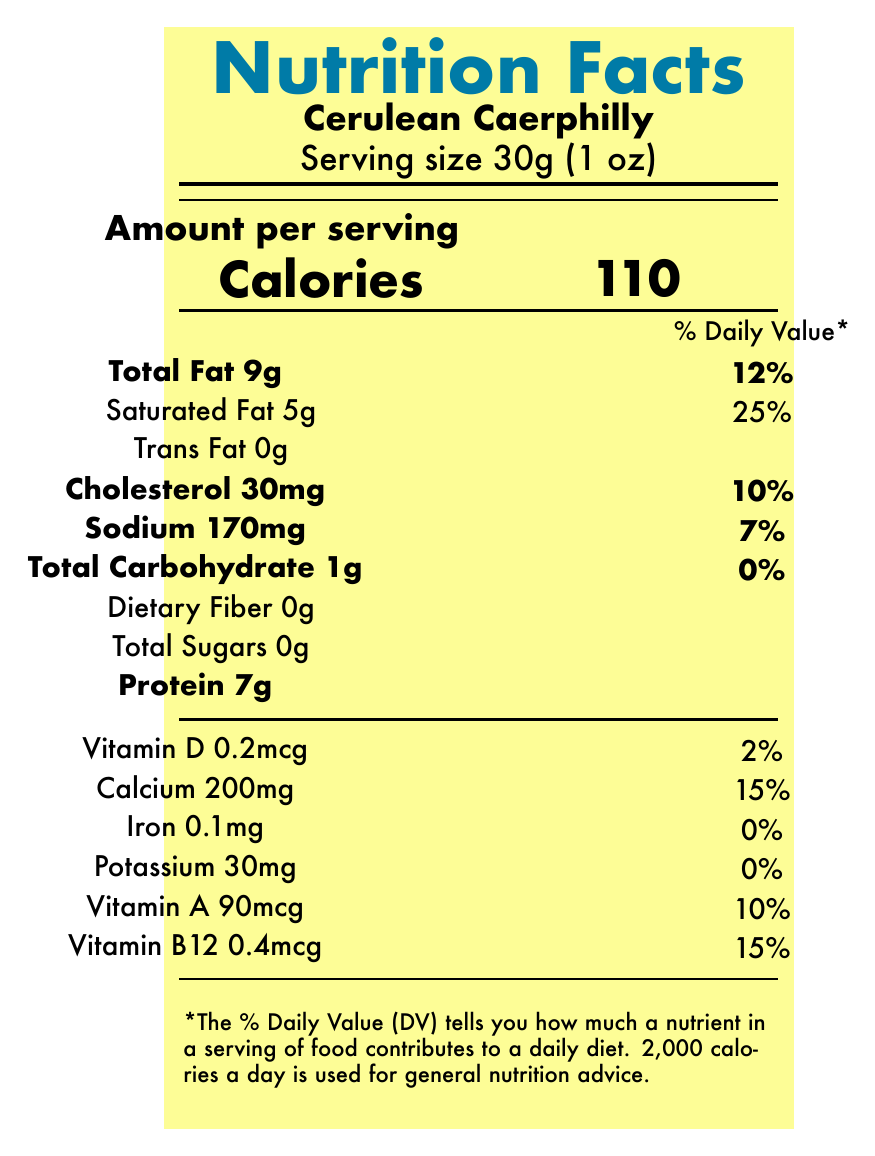what is the serving size of Cerulean Caerphilly? The document specifies the serving size right under the product name, indicating that one serving is 30 grams (1 ounce).
Answer: 30g (1 oz) how many calories are in one serving? The Nutrition Facts label clearly shows that one serving of Cerulean Caerphilly contains 110 calories.
Answer: 110 what is the total fat content per serving? The total fat per serving is listed as 9 grams, with a daily value of 12%.
Answer: 9g how much cholesterol does Cerulean Caerphilly contain per serving? According to the document, each serving contains 30 milligrams of cholesterol, which is 10% of the daily value.
Answer: 30mg how much protein is present per serving? The document states that each serving of Cerulean Caerphilly contains 7 grams of protein.
Answer: 7g how many servings are in one container of Cerulean Caerphilly? A. 4 B. 8 C. 10 D. 6 It is mentioned at the beginning of the document that there are 8 servings per container.
Answer: B what is the saturated fat content per serving? A. 2g B. 4g C. 5g D. 6g The label identifies the saturated fat content as 5 grams per serving, contributing 25% to the daily value.
Answer: C does the Cerulean Caerphilly cheese contain any trans fat? The document clearly indicates that the trans fat content per serving is 0 grams.
Answer: No is this cheese a significant source of dietary fiber? The dietary fiber content is listed as 0 grams per serving, meaning it is not a significant source of dietary fiber.
Answer: No Summarize the main idea of the document. The document mainly serves to inform consumers about the detailed nutritional content and other relevant information regarding the cheese product called Cerulean Caerphilly.
Answer: The document provides nutritional information for 'Cerulean Caerphilly' cheese, inspired by Wes Anderson's color palette. It outlines the serving size, calories, fat, cholesterol, sodium, carbohydrate, protein content, and various vitamins and minerals per serving. Additionally, it includes brief descriptions about the cheese’s ingredients, allergens, storage conditions, and producer. which method was used to achieve the unique appearance of the cheese? The document mentions that the blue-green hue of the cheese is achieved through the addition of spirulina.
Answer: The use of spirulina how much vitamin B12 does one serving contain? The nutritional label indicates that one serving contains 0.4 micrograms of vitamin B12, which is 15% of the daily value.
Answer: 0.4mcg Are there any common allergens present in Cerulean Caerphilly? The document explicitly states that the cheese contains milk, which is a common allergen.
Answer: Yes what is the amount of potassium in one serving? The document lists the potassium content as 30 milligrams per serving, contributing 0% to the daily value.
Answer: 30mg what is the recommended storage temperature for this cheese? The document advises keeping the cheese refrigerated at 4°C (39°F) or below to maintain its quality.
Answer: 4°C (39°F) or below How much total carbohydrate is found in one serving of Cerulean Caerphilly? The document notes that each serving contains 1 gram of total carbohydrate, accounting for 0% of the daily value.
Answer: 1g How long has the producer of Cerulean Caerphilly been in business? The document does not provide any details regarding the history or the duration of the producer's business operations.
Answer: Not enough information 